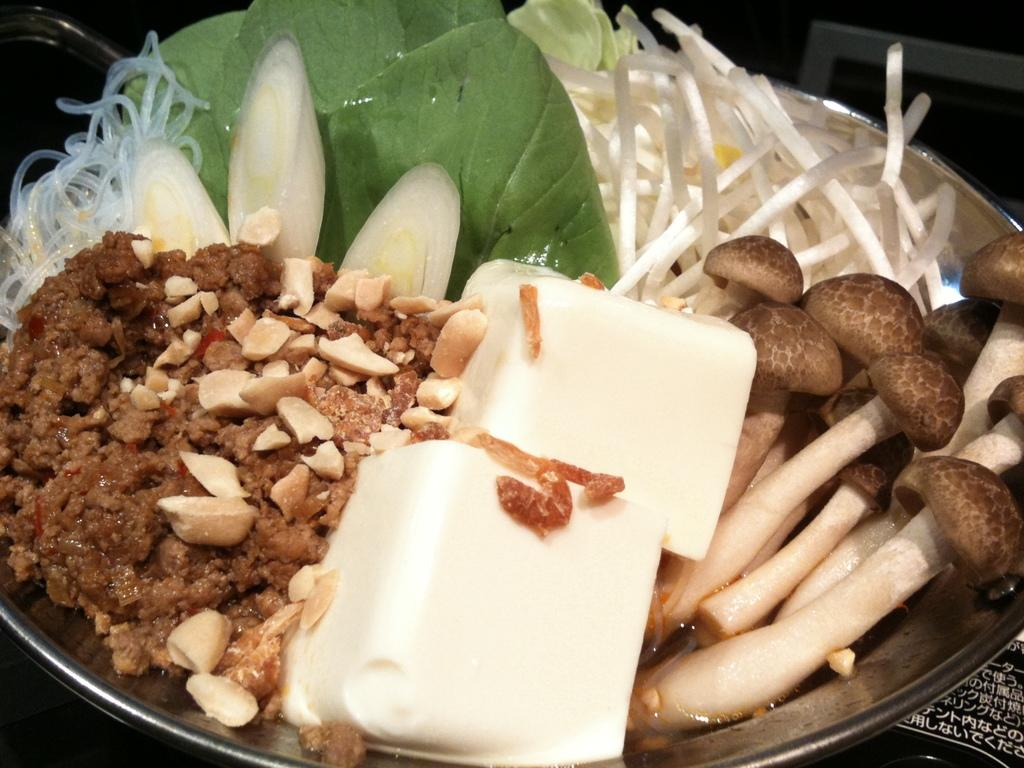What is on the plate in the image? There is a food item in the plate. What ingredients can be found in the food item? The food item contains mushrooms and onion slices. What type of coat is hanging on the cactus in the image? There is no coat or cactus present in the image; it only features a food item with mushrooms and onion slices. 